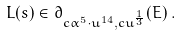Convert formula to latex. <formula><loc_0><loc_0><loc_500><loc_500>L ( s ) \in \partial _ { c \alpha ^ { 5 } \cdot u ^ { 1 4 } , c u ^ { \frac { 1 } { 3 } } } ( E ) \, .</formula> 